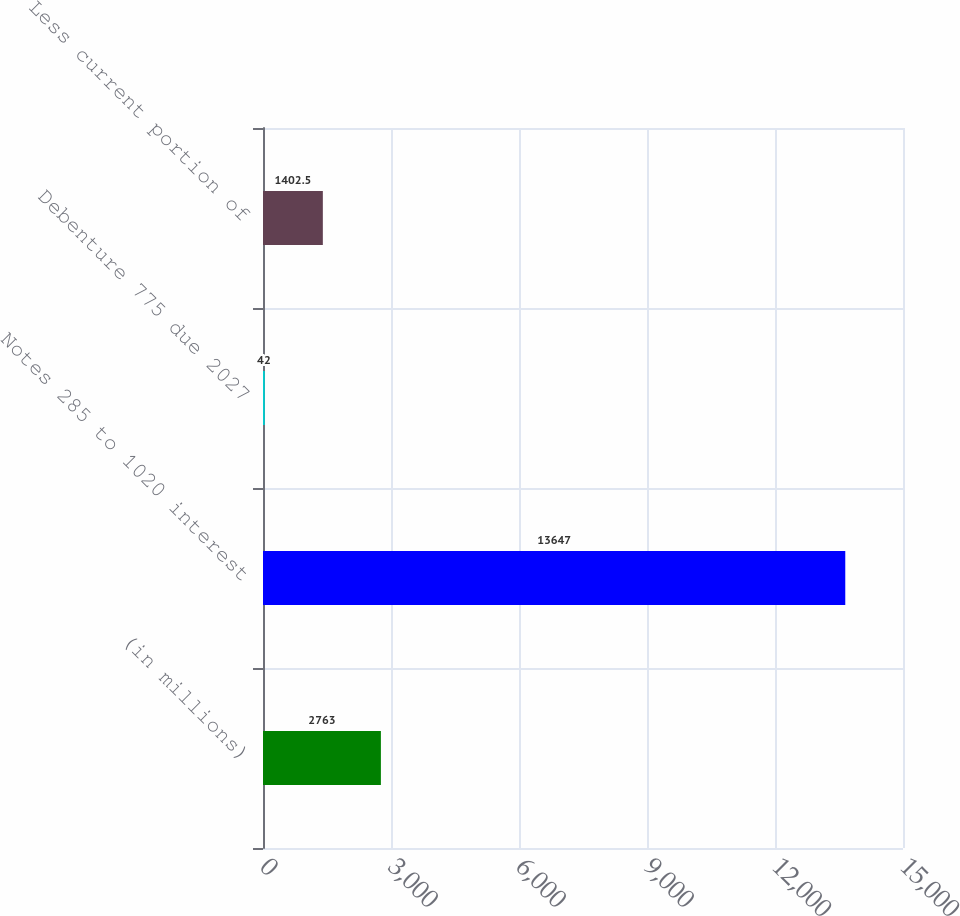Convert chart to OTSL. <chart><loc_0><loc_0><loc_500><loc_500><bar_chart><fcel>(in millions)<fcel>Notes 285 to 1020 interest<fcel>Debenture 775 due 2027<fcel>Less current portion of<nl><fcel>2763<fcel>13647<fcel>42<fcel>1402.5<nl></chart> 